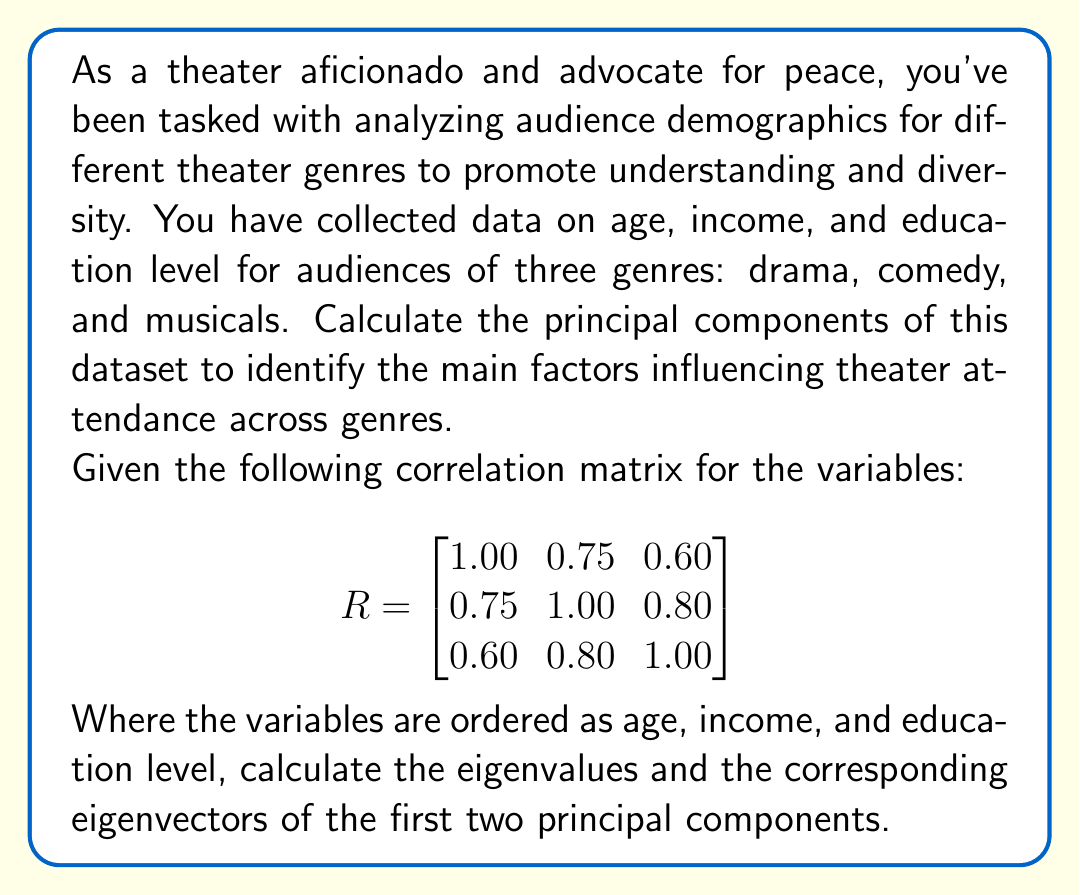Help me with this question. To calculate the principal components, we need to follow these steps:

1. Start with the correlation matrix $R$.

2. Calculate the eigenvalues by solving the characteristic equation:
   $\det(R - \lambda I) = 0$

   $$\begin{vmatrix}
   1.00 - \lambda & 0.75 & 0.60 \\
   0.75 & 1.00 - \lambda & 0.80 \\
   0.60 & 0.80 & 1.00 - \lambda
   \end{vmatrix} = 0$$

   This yields the cubic equation:
   $-\lambda^3 + 3\lambda^2 - 0.71\lambda - 0.456 = 0$

3. Solve this equation to get the eigenvalues:
   $\lambda_1 \approx 2.48$
   $\lambda_2 \approx 0.42$
   $\lambda_3 \approx 0.10$

4. For each eigenvalue, solve $(R - \lambda_i I)\mathbf{v}_i = \mathbf{0}$ to find the corresponding eigenvector.

For $\lambda_1 \approx 2.48$:
$$\begin{bmatrix}
-1.48 & 0.75 & 0.60 \\
0.75 & -1.48 & 0.80 \\
0.60 & 0.80 & -1.48
\end{bmatrix}\mathbf{v}_1 = \mathbf{0}$$

Solving this system gives us (after normalization):
$\mathbf{v}_1 \approx [0.55, 0.61, 0.57]^T$

For $\lambda_2 \approx 0.42$:
$$\begin{bmatrix}
0.58 & 0.75 & 0.60 \\
0.75 & 0.58 & 0.80 \\
0.60 & 0.80 & 0.58
\end{bmatrix}\mathbf{v}_2 = \mathbf{0}$$

Solving this system gives us (after normalization):
$\mathbf{v}_2 \approx [-0.76, 0.09, 0.64]^T$

5. These eigenvectors represent the loadings of each variable on the principal components. The first principal component (PC1) explains about 82.7% of the total variance ($2.48 / 3$), while the second (PC2) explains about 14% ($0.42 / 3$).
Answer: The first two principal components are:

PC1: eigenvalue $\lambda_1 \approx 2.48$, eigenvector $\mathbf{v}_1 \approx [0.55, 0.61, 0.57]^T$
PC2: eigenvalue $\lambda_2 \approx 0.42$, eigenvector $\mathbf{v}_2 \approx [-0.76, 0.09, 0.64]^T$ 